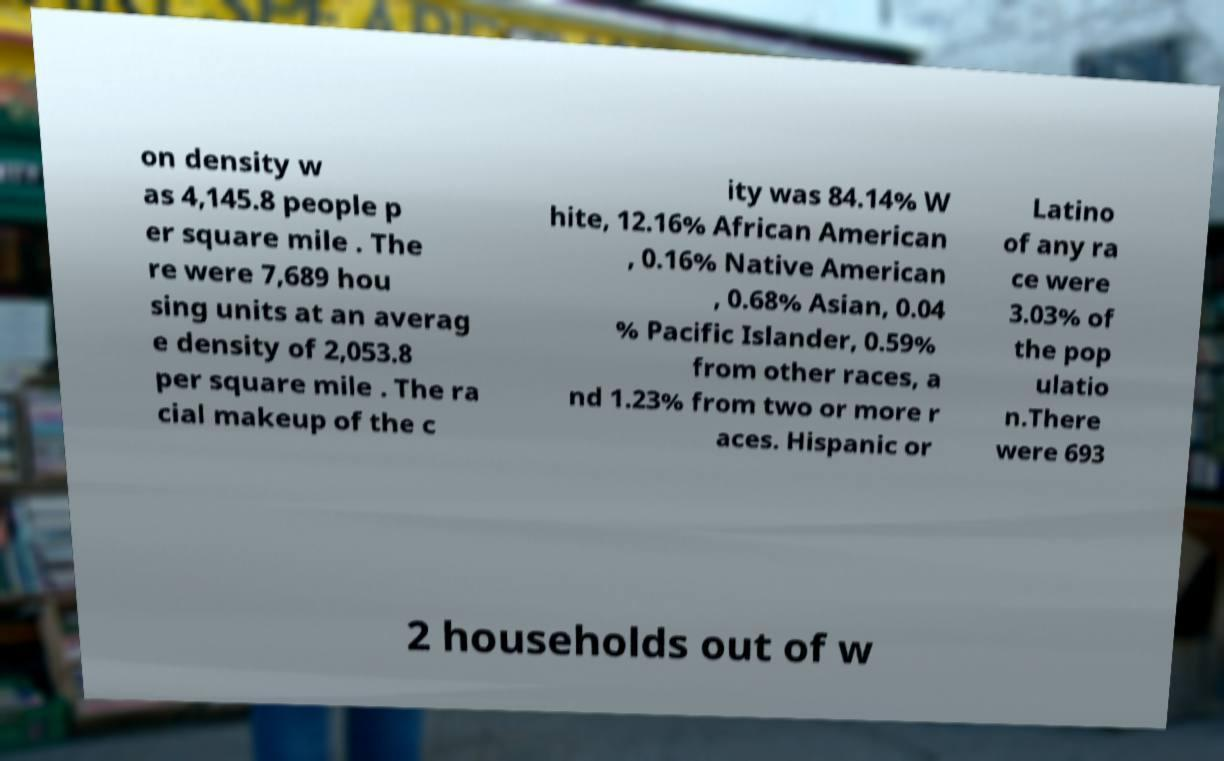I need the written content from this picture converted into text. Can you do that? on density w as 4,145.8 people p er square mile . The re were 7,689 hou sing units at an averag e density of 2,053.8 per square mile . The ra cial makeup of the c ity was 84.14% W hite, 12.16% African American , 0.16% Native American , 0.68% Asian, 0.04 % Pacific Islander, 0.59% from other races, a nd 1.23% from two or more r aces. Hispanic or Latino of any ra ce were 3.03% of the pop ulatio n.There were 693 2 households out of w 